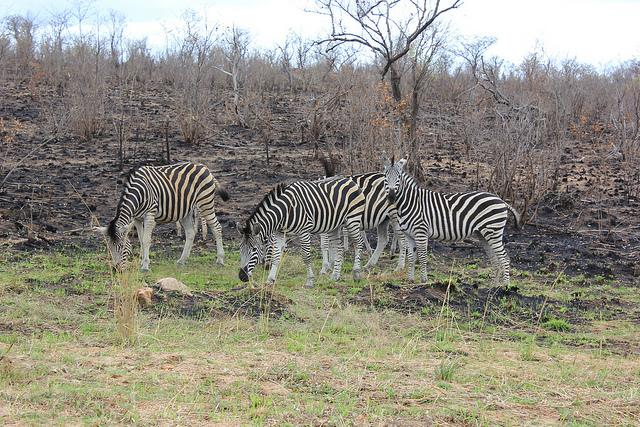What are these animals known for? stripes 